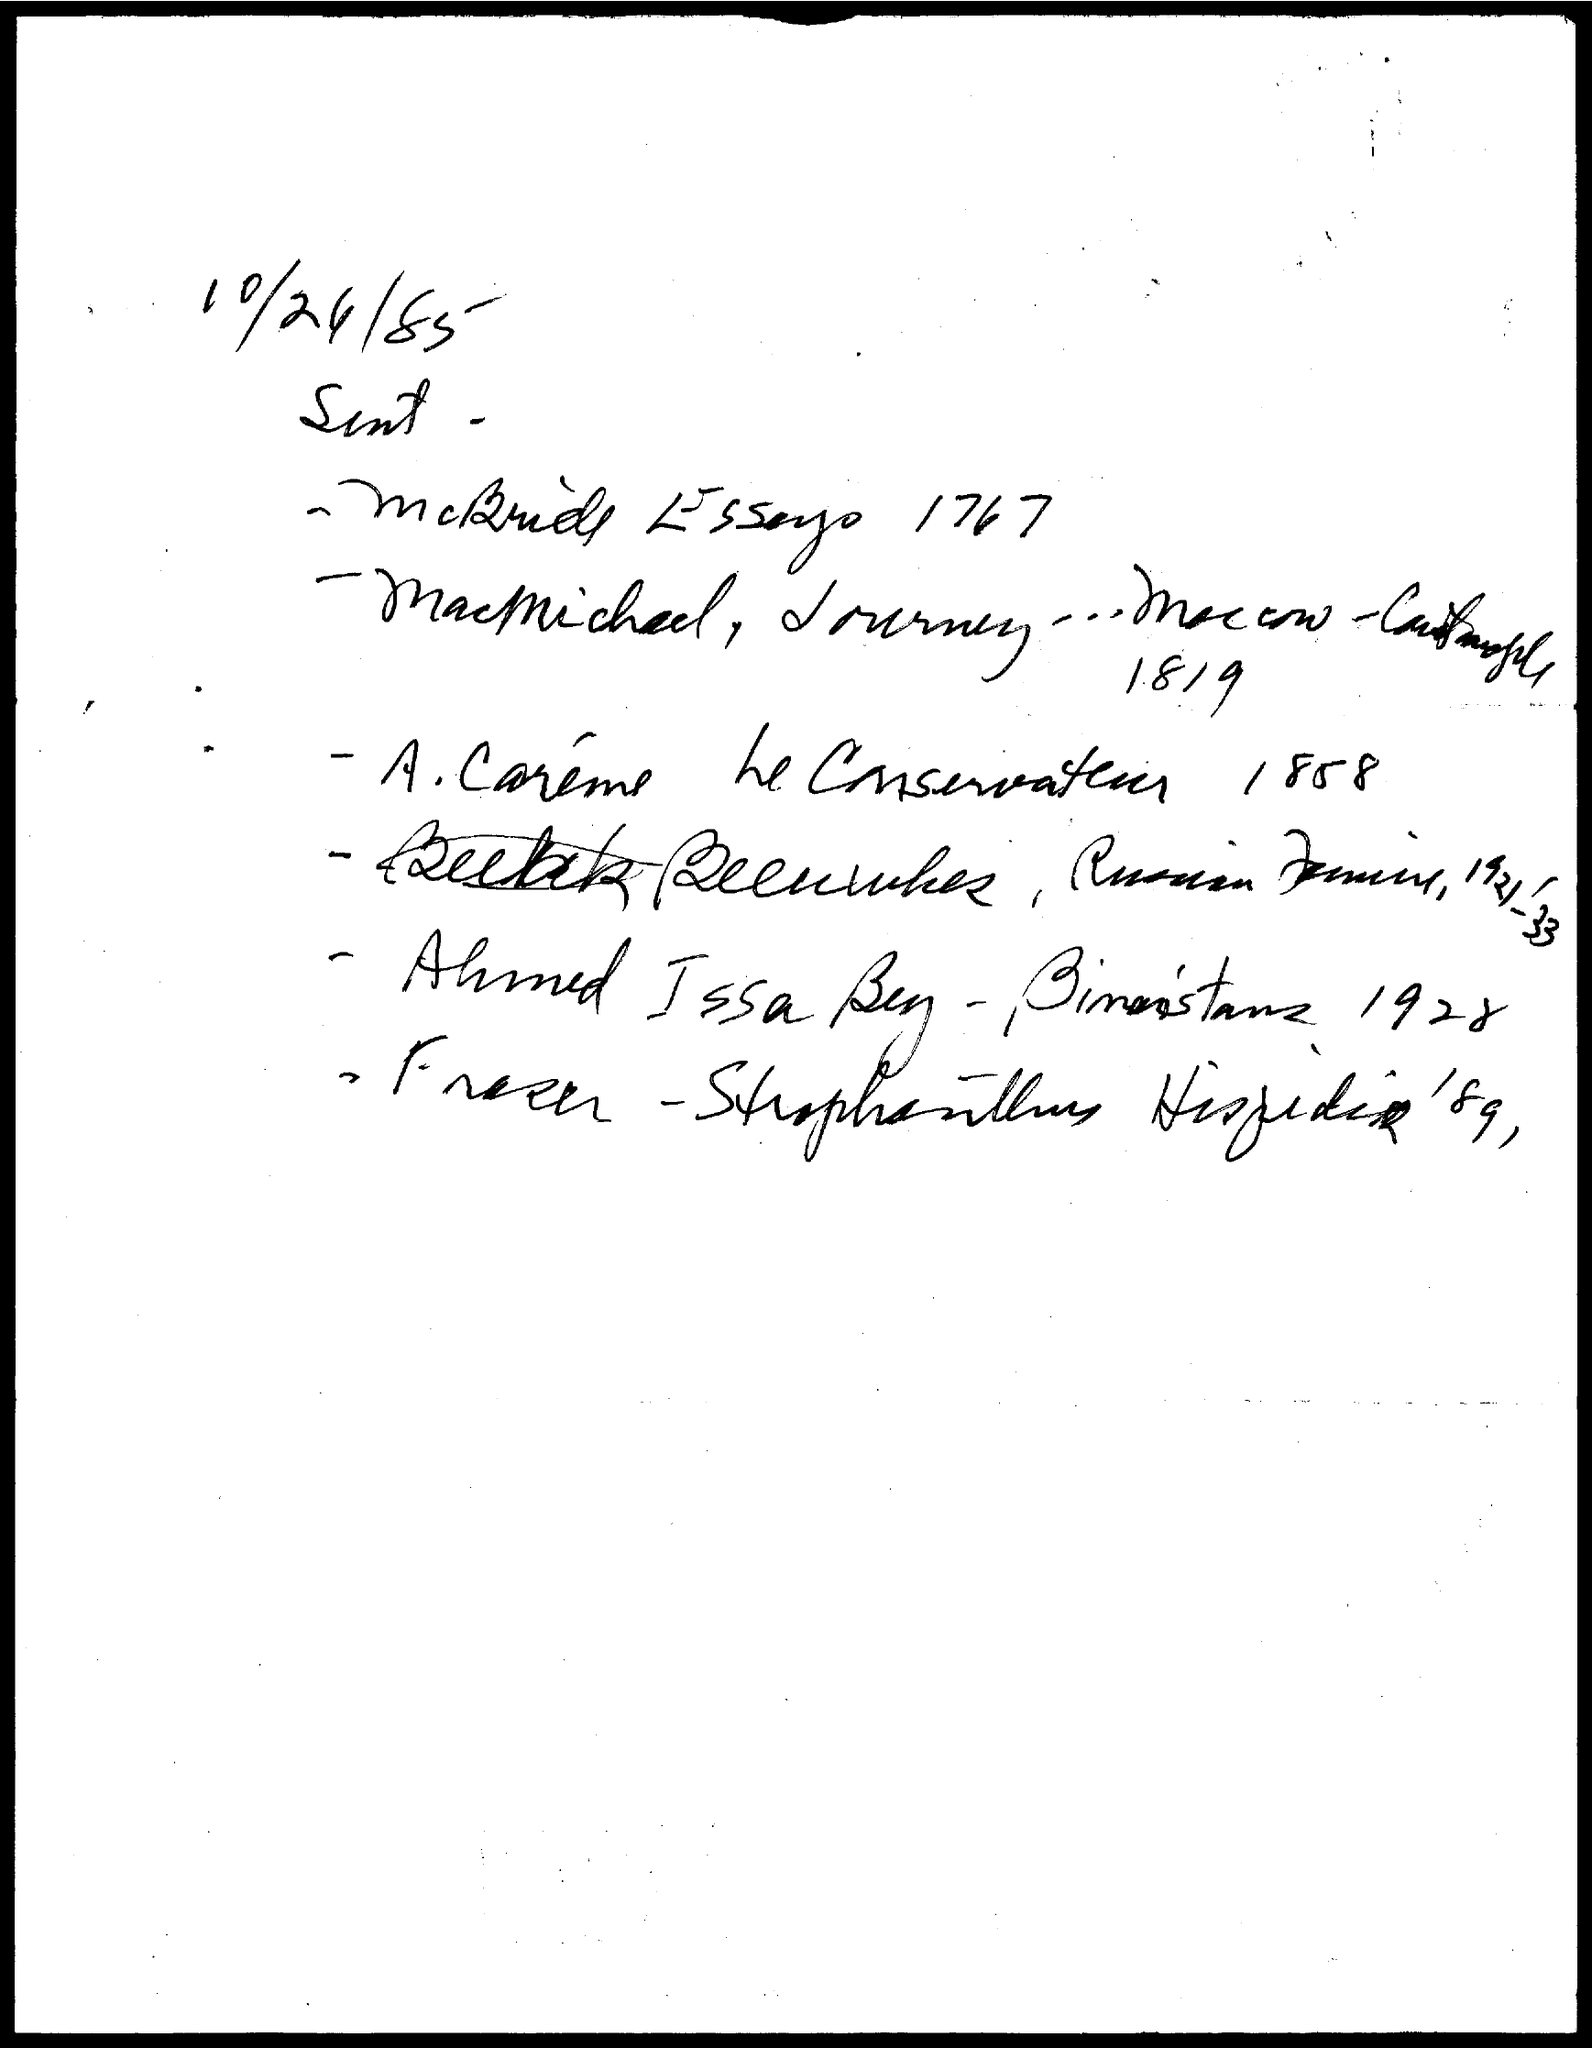What is the date on the document?
Offer a terse response. 10/24/85. 